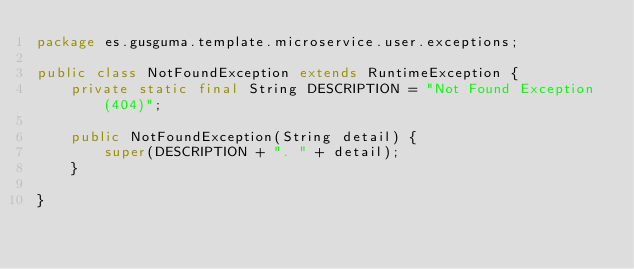<code> <loc_0><loc_0><loc_500><loc_500><_Java_>package es.gusguma.template.microservice.user.exceptions;

public class NotFoundException extends RuntimeException {
    private static final String DESCRIPTION = "Not Found Exception (404)";

    public NotFoundException(String detail) {
        super(DESCRIPTION + ". " + detail);
    }

}
</code> 